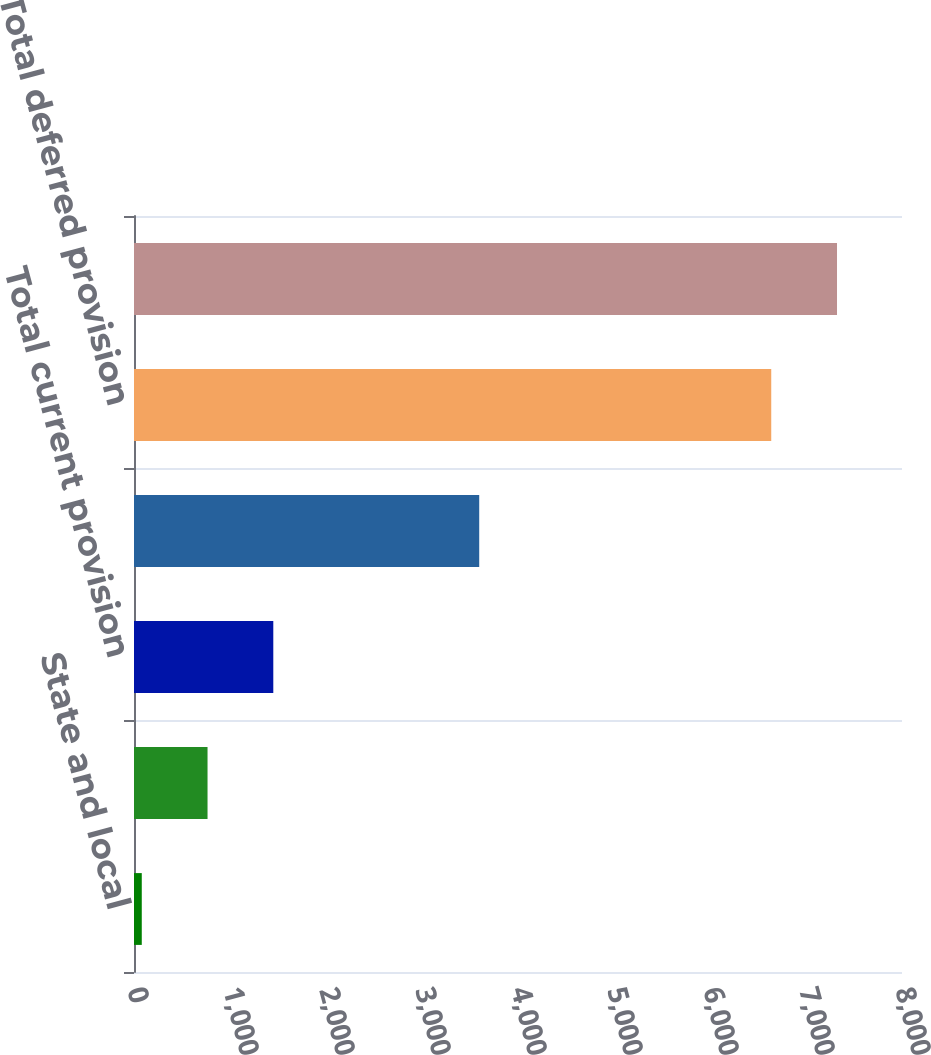<chart> <loc_0><loc_0><loc_500><loc_500><bar_chart><fcel>State and local<fcel>Foreign<fcel>Total current provision<fcel>Federal<fcel>Total deferred provision<fcel>Provision for income taxes<nl><fcel>81<fcel>766<fcel>1451<fcel>3596<fcel>6638<fcel>7323<nl></chart> 